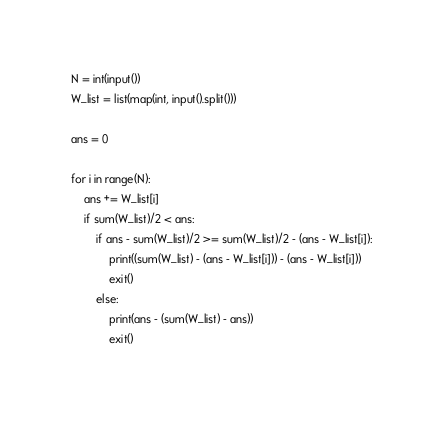Convert code to text. <code><loc_0><loc_0><loc_500><loc_500><_Python_>N = int(input())
W_list = list(map(int, input().split()))

ans = 0

for i in range(N):
    ans += W_list[i]
    if sum(W_list)/2 < ans:
        if ans - sum(W_list)/2 >= sum(W_list)/2 - (ans - W_list[i]):
            print((sum(W_list) - (ans - W_list[i])) - (ans - W_list[i]))
            exit()
        else:
            print(ans - (sum(W_list) - ans))
            exit()</code> 